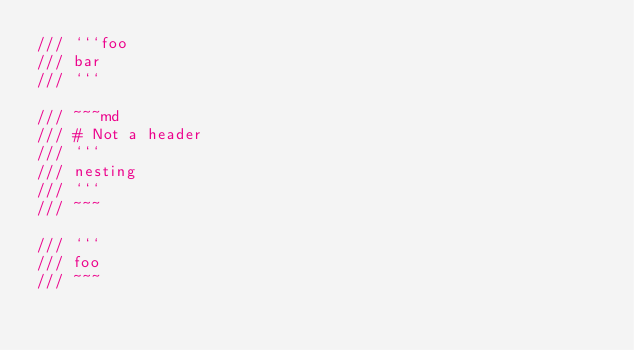<code> <loc_0><loc_0><loc_500><loc_500><_Rust_>/// ```foo
/// bar
/// ```

/// ~~~md
/// # Not a header
/// ```
/// nesting
/// ```
/// ~~~

/// ```
/// foo
/// ~~~
</code> 